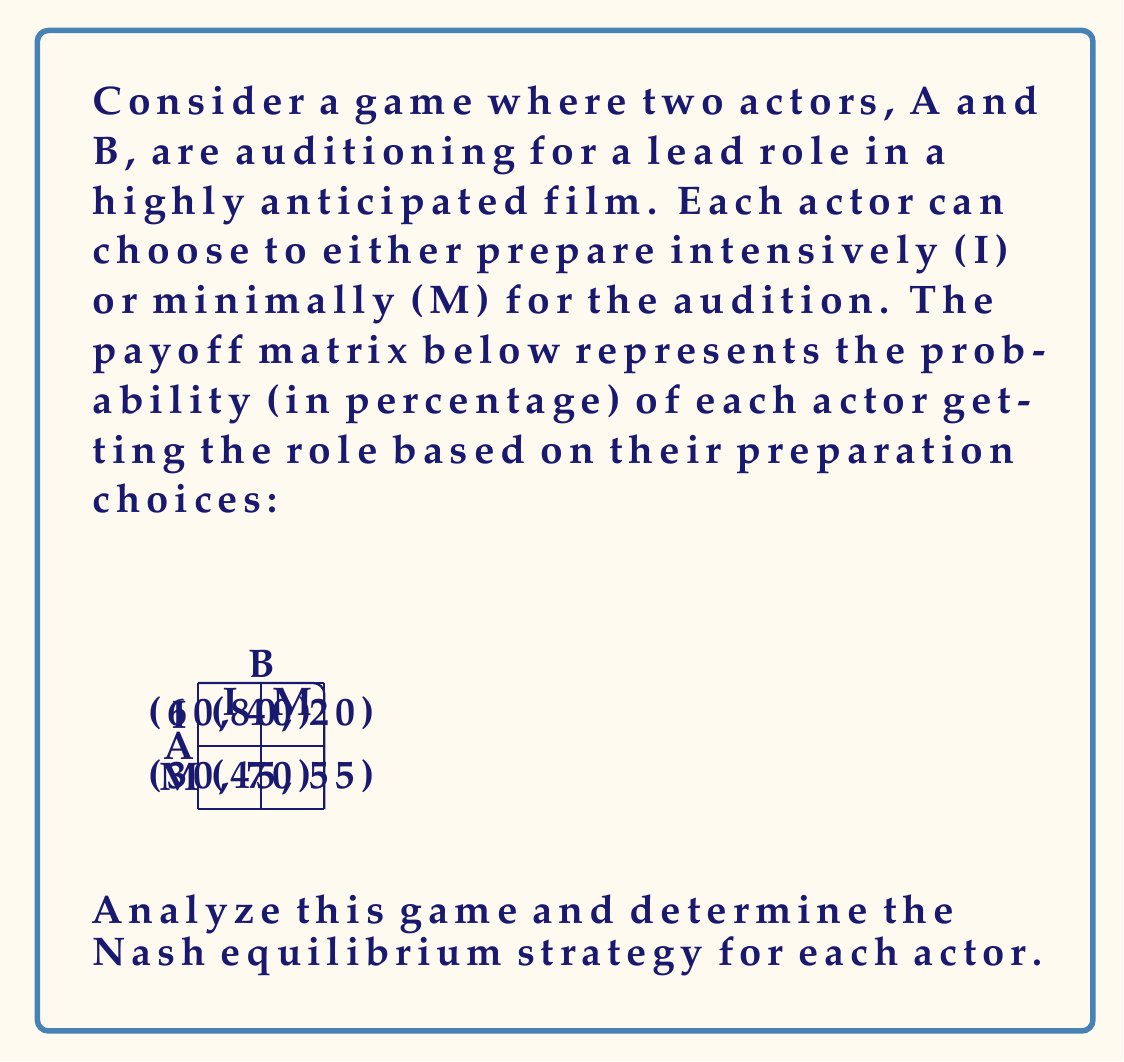Help me with this question. To find the Nash equilibrium, we need to determine the best response for each actor given the other actor's strategy.

Step 1: Analyze Actor A's best responses
- If B chooses I:
  A chooses I: 60% chance
  A chooses M: 30% chance
  Best response: I
- If B chooses M:
  A chooses I: 80% chance
  A chooses M: 45% chance
  Best response: I

Step 2: Analyze Actor B's best responses
- If A chooses I:
  B chooses I: 40% chance
  B chooses M: 20% chance
  Best response: I
- If A chooses M:
  B chooses I: 70% chance
  B chooses M: 55% chance
  Best response: I

Step 3: Identify the Nash equilibrium
Since both actors' best response is to choose I regardless of the other actor's choice, the Nash equilibrium is (I, I).

Step 4: Verify the equilibrium
At (I, I), neither actor can unilaterally improve their outcome:
- If A switches to M: 30% < 60%
- If B switches to M: 20% < 40%

Therefore, (I, I) is indeed the Nash equilibrium.
Answer: (I, I) 